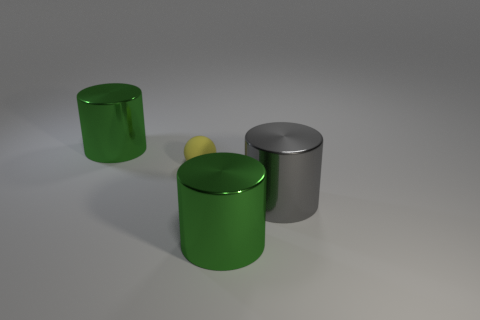Are there any other things that have the same material as the sphere?
Offer a very short reply. No. Is the color of the small matte thing the same as the metal cylinder that is left of the yellow object?
Your answer should be compact. No. The large gray thing is what shape?
Your response must be concise. Cylinder. There is a green thing in front of the gray metal cylinder that is in front of the thing that is to the left of the tiny yellow ball; what size is it?
Your answer should be very brief. Large. What number of other things are the same shape as the tiny yellow rubber object?
Your answer should be very brief. 0. Is the shape of the green object that is left of the ball the same as the green object that is in front of the gray cylinder?
Give a very brief answer. Yes. What number of cylinders are green things or tiny things?
Offer a terse response. 2. There is a sphere that is to the left of the big gray thing that is behind the object in front of the gray metallic object; what is it made of?
Offer a very short reply. Rubber. How many other objects are there of the same size as the gray metal thing?
Offer a terse response. 2. Is the number of tiny matte things that are to the right of the small yellow thing greater than the number of big green shiny objects?
Ensure brevity in your answer.  No. 